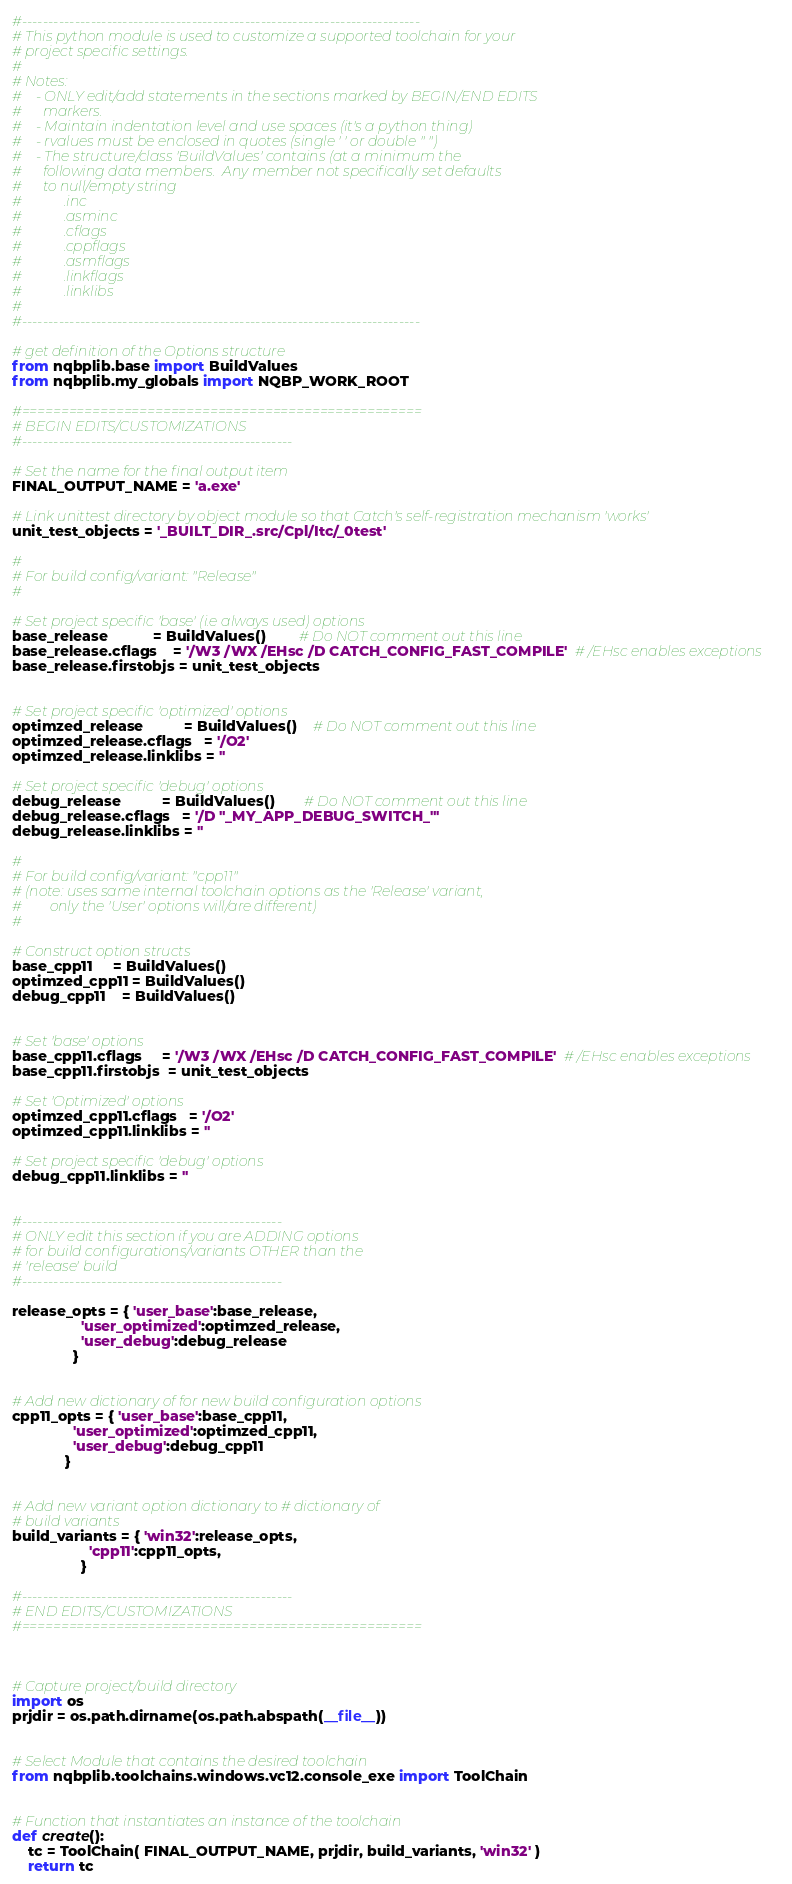<code> <loc_0><loc_0><loc_500><loc_500><_Python_>#---------------------------------------------------------------------------
# This python module is used to customize a supported toolchain for your 
# project specific settings.
#
# Notes:
#    - ONLY edit/add statements in the sections marked by BEGIN/END EDITS
#      markers.
#    - Maintain indentation level and use spaces (it's a python thing) 
#    - rvalues must be enclosed in quotes (single ' ' or double " ")
#    - The structure/class 'BuildValues' contains (at a minimum the
#      following data members.  Any member not specifically set defaults
#      to null/empty string
#            .inc 
#            .asminc
#            .cflags
#            .cppflags
#            .asmflags
#            .linkflags
#            .linklibs
#           
#---------------------------------------------------------------------------

# get definition of the Options structure
from nqbplib.base import BuildValues
from nqbplib.my_globals import NQBP_WORK_ROOT

#===================================================
# BEGIN EDITS/CUSTOMIZATIONS
#---------------------------------------------------

# Set the name for the final output item
FINAL_OUTPUT_NAME = 'a.exe'

# Link unittest directory by object module so that Catch's self-registration mechanism 'works'
unit_test_objects = '_BUILT_DIR_.src/Cpl/Itc/_0test'

#
# For build config/variant: "Release" 
#

# Set project specific 'base' (i.e always used) options
base_release           = BuildValues()        # Do NOT comment out this line
base_release.cflags    = '/W3 /WX /EHsc /D CATCH_CONFIG_FAST_COMPILE'  # /EHsc enables exceptions
base_release.firstobjs = unit_test_objects


# Set project specific 'optimized' options
optimzed_release          = BuildValues()    # Do NOT comment out this line
optimzed_release.cflags   = '/O2'
optimzed_release.linklibs = ''

# Set project specific 'debug' options
debug_release          = BuildValues()       # Do NOT comment out this line
debug_release.cflags   = '/D "_MY_APP_DEBUG_SWITCH_"'
debug_release.linklibs = ''

#
# For build config/variant: "cpp11"
# (note: uses same internal toolchain options as the 'Release' variant, 
#        only the 'User' options will/are different)
#

# Construct option structs
base_cpp11     = BuildValues()  
optimzed_cpp11 = BuildValues()
debug_cpp11    = BuildValues()


# Set 'base' options
base_cpp11.cflags     = '/W3 /WX /EHsc /D CATCH_CONFIG_FAST_COMPILE'  # /EHsc enables exceptions
base_cpp11.firstobjs  = unit_test_objects

# Set 'Optimized' options
optimzed_cpp11.cflags   = '/O2'
optimzed_cpp11.linklibs = ''

# Set project specific 'debug' options
debug_cpp11.linklibs = ''


#-------------------------------------------------
# ONLY edit this section if you are ADDING options
# for build configurations/variants OTHER than the
# 'release' build
#-------------------------------------------------

release_opts = { 'user_base':base_release, 
                 'user_optimized':optimzed_release, 
                 'user_debug':debug_release
               }
               
               
# Add new dictionary of for new build configuration options
cpp11_opts = { 'user_base':base_cpp11, 
               'user_optimized':optimzed_cpp11, 
               'user_debug':debug_cpp11
             }
  
        
# Add new variant option dictionary to # dictionary of 
# build variants
build_variants = { 'win32':release_opts,
                   'cpp11':cpp11_opts,
                 }    

#---------------------------------------------------
# END EDITS/CUSTOMIZATIONS
#===================================================



# Capture project/build directory
import os
prjdir = os.path.dirname(os.path.abspath(__file__))


# Select Module that contains the desired toolchain
from nqbplib.toolchains.windows.vc12.console_exe import ToolChain


# Function that instantiates an instance of the toolchain
def create():
    tc = ToolChain( FINAL_OUTPUT_NAME, prjdir, build_variants, 'win32' )
    return tc 
</code> 